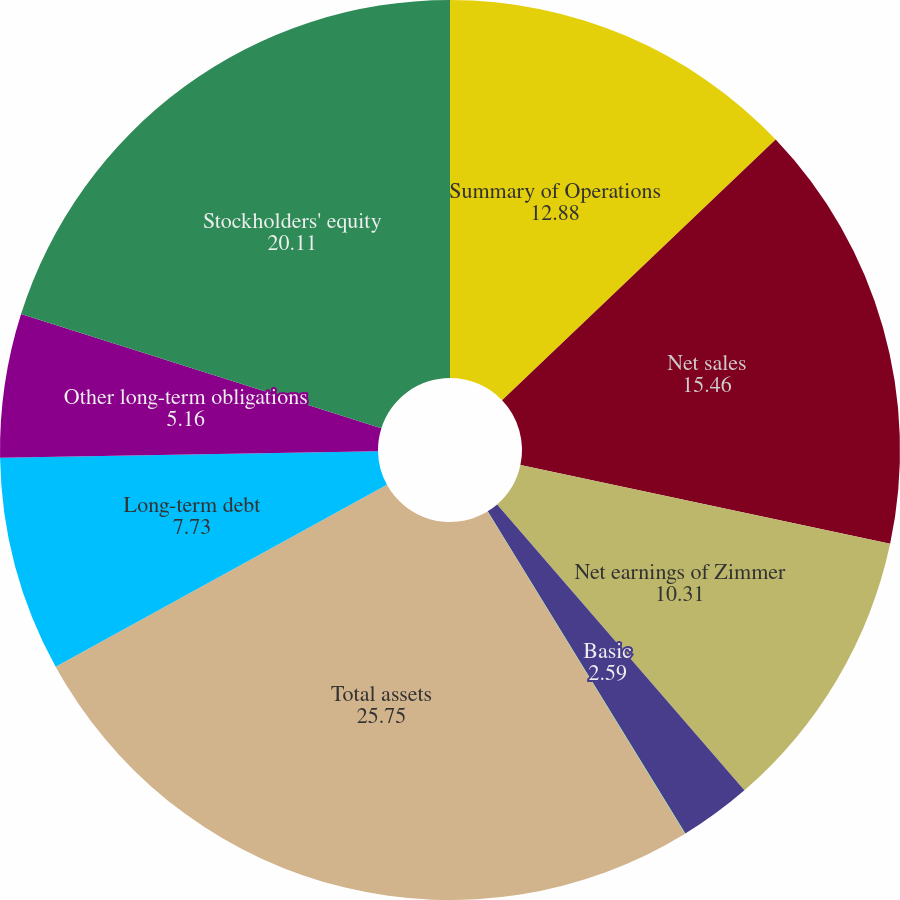Convert chart. <chart><loc_0><loc_0><loc_500><loc_500><pie_chart><fcel>Summary of Operations<fcel>Net sales<fcel>Net earnings of Zimmer<fcel>Basic<fcel>Diluted<fcel>Total assets<fcel>Long-term debt<fcel>Other long-term obligations<fcel>Stockholders' equity<nl><fcel>12.88%<fcel>15.46%<fcel>10.31%<fcel>2.59%<fcel>0.01%<fcel>25.75%<fcel>7.73%<fcel>5.16%<fcel>20.11%<nl></chart> 